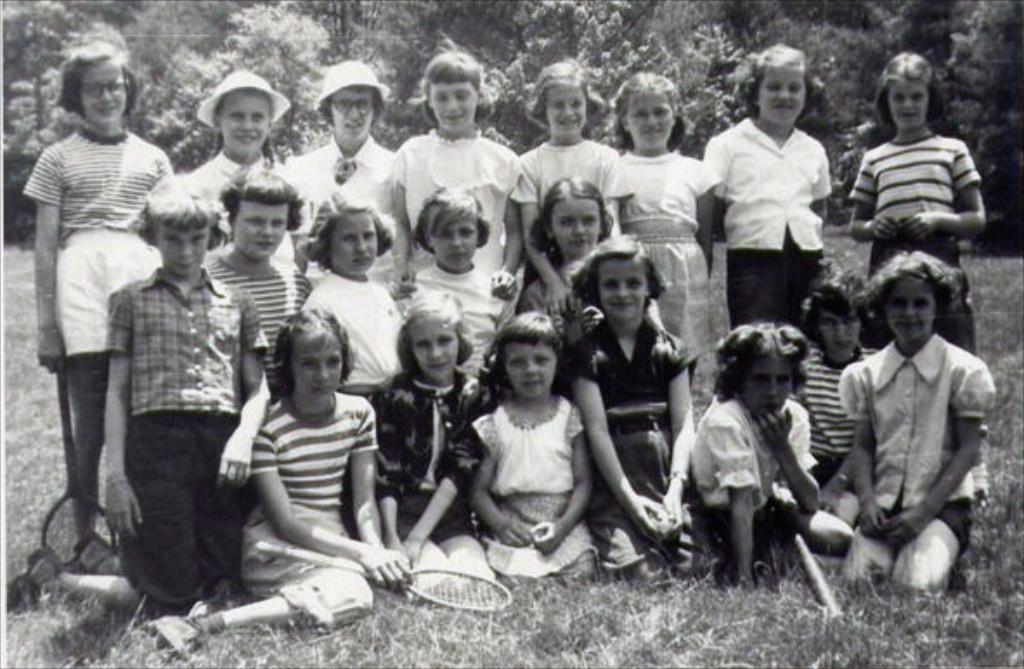Can you describe this image briefly? This is a black and white picture. Here we can see few children on the ground. This is grass. In the background there are trees. 